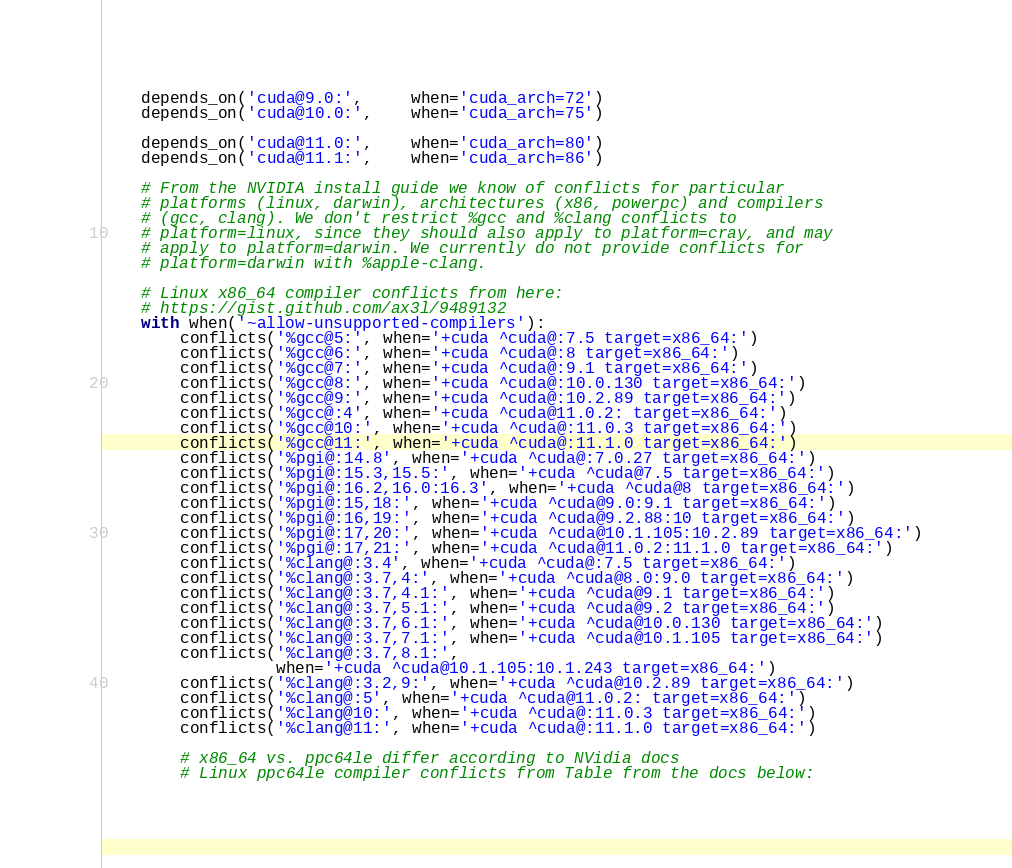Convert code to text. <code><loc_0><loc_0><loc_500><loc_500><_Python_>    depends_on('cuda@9.0:',     when='cuda_arch=72')
    depends_on('cuda@10.0:',    when='cuda_arch=75')

    depends_on('cuda@11.0:',    when='cuda_arch=80')
    depends_on('cuda@11.1:',    when='cuda_arch=86')

    # From the NVIDIA install guide we know of conflicts for particular
    # platforms (linux, darwin), architectures (x86, powerpc) and compilers
    # (gcc, clang). We don't restrict %gcc and %clang conflicts to
    # platform=linux, since they should also apply to platform=cray, and may
    # apply to platform=darwin. We currently do not provide conflicts for
    # platform=darwin with %apple-clang.

    # Linux x86_64 compiler conflicts from here:
    # https://gist.github.com/ax3l/9489132
    with when('~allow-unsupported-compilers'):
        conflicts('%gcc@5:', when='+cuda ^cuda@:7.5 target=x86_64:')
        conflicts('%gcc@6:', when='+cuda ^cuda@:8 target=x86_64:')
        conflicts('%gcc@7:', when='+cuda ^cuda@:9.1 target=x86_64:')
        conflicts('%gcc@8:', when='+cuda ^cuda@:10.0.130 target=x86_64:')
        conflicts('%gcc@9:', when='+cuda ^cuda@:10.2.89 target=x86_64:')
        conflicts('%gcc@:4', when='+cuda ^cuda@11.0.2: target=x86_64:')
        conflicts('%gcc@10:', when='+cuda ^cuda@:11.0.3 target=x86_64:')
        conflicts('%gcc@11:', when='+cuda ^cuda@:11.1.0 target=x86_64:')
        conflicts('%pgi@:14.8', when='+cuda ^cuda@:7.0.27 target=x86_64:')
        conflicts('%pgi@:15.3,15.5:', when='+cuda ^cuda@7.5 target=x86_64:')
        conflicts('%pgi@:16.2,16.0:16.3', when='+cuda ^cuda@8 target=x86_64:')
        conflicts('%pgi@:15,18:', when='+cuda ^cuda@9.0:9.1 target=x86_64:')
        conflicts('%pgi@:16,19:', when='+cuda ^cuda@9.2.88:10 target=x86_64:')
        conflicts('%pgi@:17,20:', when='+cuda ^cuda@10.1.105:10.2.89 target=x86_64:')
        conflicts('%pgi@:17,21:', when='+cuda ^cuda@11.0.2:11.1.0 target=x86_64:')
        conflicts('%clang@:3.4', when='+cuda ^cuda@:7.5 target=x86_64:')
        conflicts('%clang@:3.7,4:', when='+cuda ^cuda@8.0:9.0 target=x86_64:')
        conflicts('%clang@:3.7,4.1:', when='+cuda ^cuda@9.1 target=x86_64:')
        conflicts('%clang@:3.7,5.1:', when='+cuda ^cuda@9.2 target=x86_64:')
        conflicts('%clang@:3.7,6.1:', when='+cuda ^cuda@10.0.130 target=x86_64:')
        conflicts('%clang@:3.7,7.1:', when='+cuda ^cuda@10.1.105 target=x86_64:')
        conflicts('%clang@:3.7,8.1:',
                  when='+cuda ^cuda@10.1.105:10.1.243 target=x86_64:')
        conflicts('%clang@:3.2,9:', when='+cuda ^cuda@10.2.89 target=x86_64:')
        conflicts('%clang@:5', when='+cuda ^cuda@11.0.2: target=x86_64:')
        conflicts('%clang@10:', when='+cuda ^cuda@:11.0.3 target=x86_64:')
        conflicts('%clang@11:', when='+cuda ^cuda@:11.1.0 target=x86_64:')

        # x86_64 vs. ppc64le differ according to NVidia docs
        # Linux ppc64le compiler conflicts from Table from the docs below:</code> 